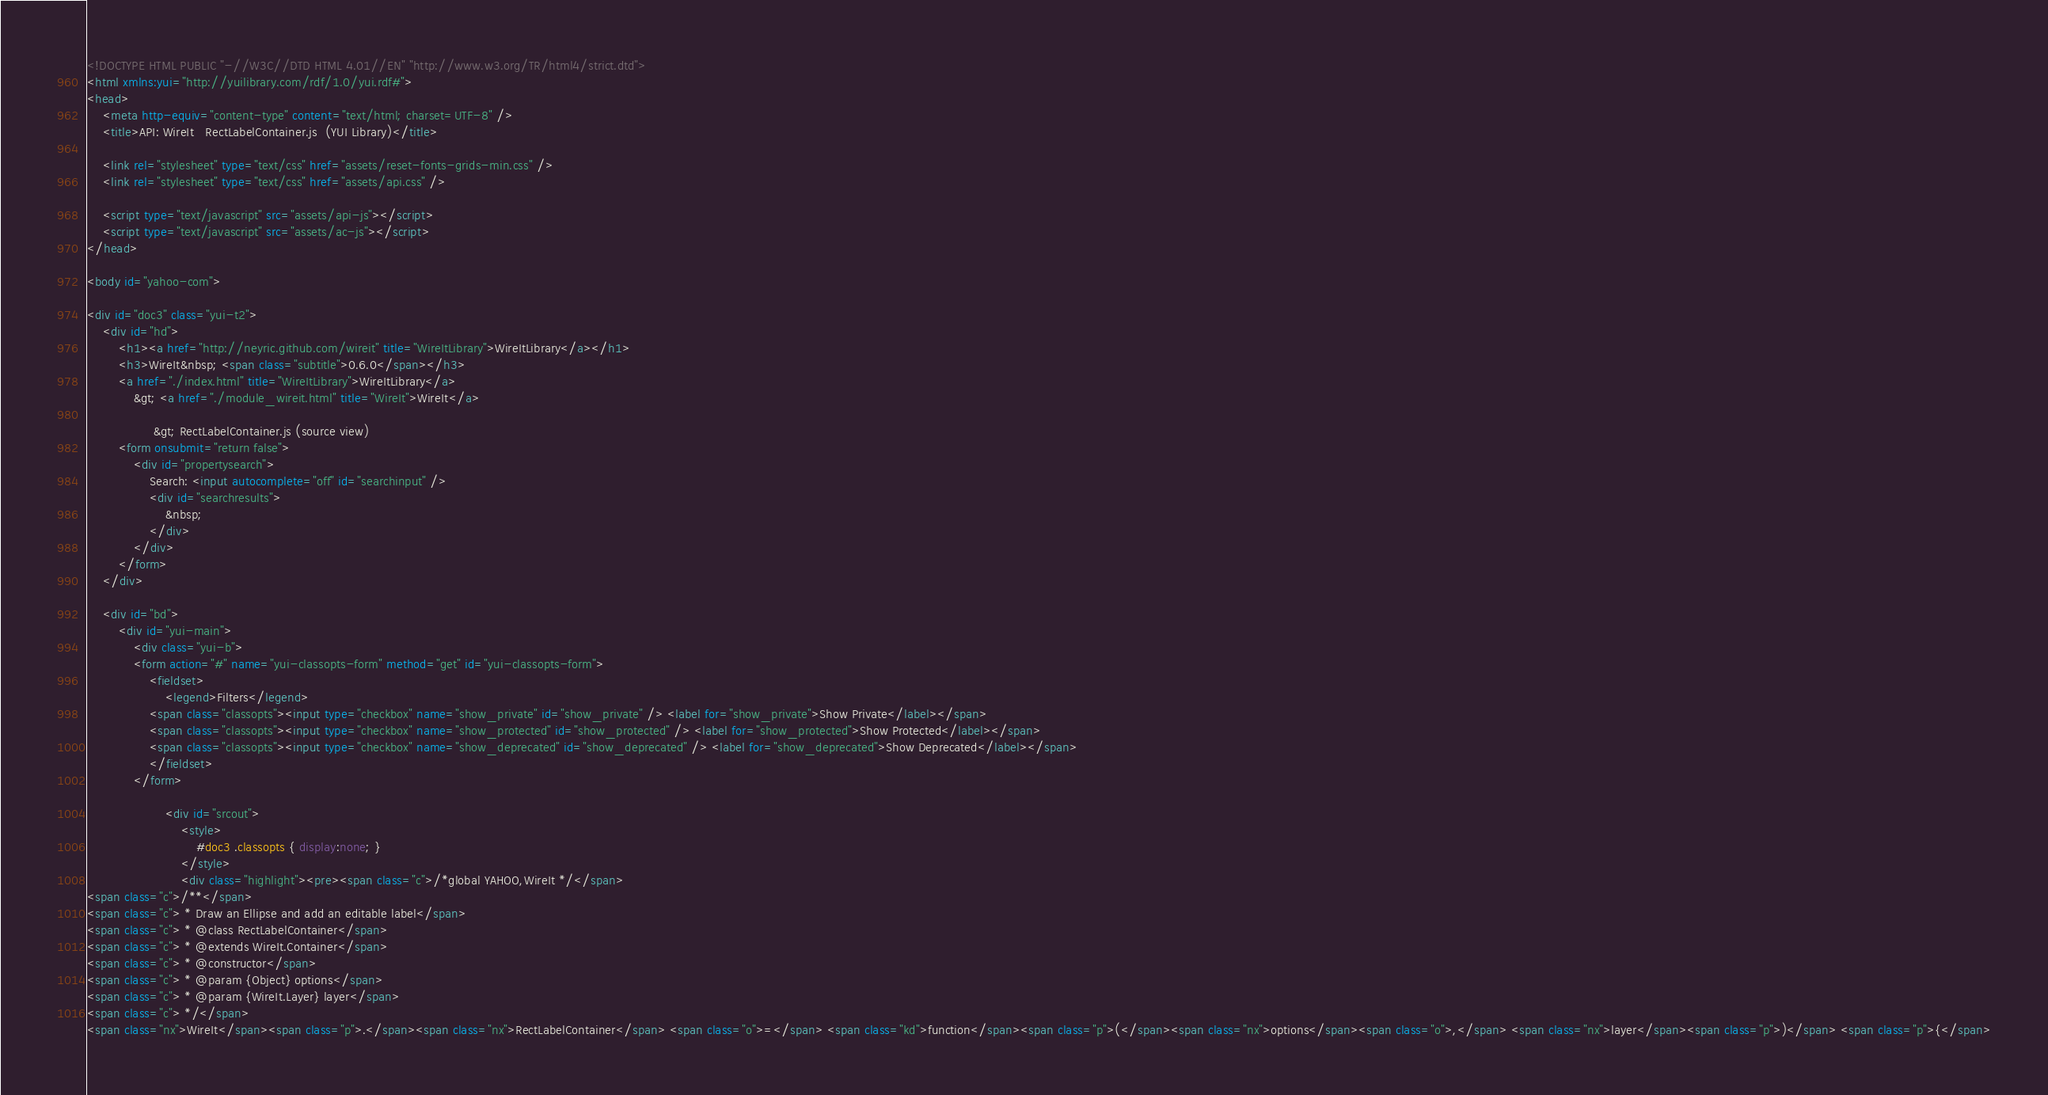Convert code to text. <code><loc_0><loc_0><loc_500><loc_500><_HTML_><!DOCTYPE HTML PUBLIC "-//W3C//DTD HTML 4.01//EN" "http://www.w3.org/TR/html4/strict.dtd">
<html xmlns:yui="http://yuilibrary.com/rdf/1.0/yui.rdf#">
<head>
    <meta http-equiv="content-type" content="text/html; charset=UTF-8" />
	<title>API: WireIt   RectLabelContainer.js  (YUI Library)</title>

	<link rel="stylesheet" type="text/css" href="assets/reset-fonts-grids-min.css" />
	<link rel="stylesheet" type="text/css" href="assets/api.css" />

    <script type="text/javascript" src="assets/api-js"></script>
    <script type="text/javascript" src="assets/ac-js"></script>
</head>

<body id="yahoo-com">

<div id="doc3" class="yui-t2">
	<div id="hd">
        <h1><a href="http://neyric.github.com/wireit" title="WireItLibrary">WireItLibrary</a></h1>
        <h3>WireIt&nbsp; <span class="subtitle">0.6.0</span></h3>
        <a href="./index.html" title="WireItLibrary">WireItLibrary</a> 
            &gt; <a href="./module_wireit.html" title="WireIt">WireIt</a>
                
                 &gt; RectLabelContainer.js (source view) 
        <form onsubmit="return false">
            <div id="propertysearch">
                Search: <input autocomplete="off" id="searchinput" />
                <div id="searchresults">
                    &nbsp;
                </div>
            </div>
        </form>
	</div>

	<div id="bd">
		<div id="yui-main">
			<div class="yui-b">
            <form action="#" name="yui-classopts-form" method="get" id="yui-classopts-form">
                <fieldset>
                    <legend>Filters</legend>
                <span class="classopts"><input type="checkbox" name="show_private" id="show_private" /> <label for="show_private">Show Private</label></span>
                <span class="classopts"><input type="checkbox" name="show_protected" id="show_protected" /> <label for="show_protected">Show Protected</label></span>
                <span class="classopts"><input type="checkbox" name="show_deprecated" id="show_deprecated" /> <label for="show_deprecated">Show Deprecated</label></span>
                </fieldset>
            </form>

                    <div id="srcout">
                        <style>
                            #doc3 .classopts { display:none; }
                        </style>
                        <div class="highlight"><pre><span class="c">/*global YAHOO,WireIt */</span>
<span class="c">/**</span>
<span class="c"> * Draw an Ellipse and add an editable label</span>
<span class="c"> * @class RectLabelContainer</span>
<span class="c"> * @extends WireIt.Container</span>
<span class="c"> * @constructor</span>
<span class="c"> * @param {Object} options</span>
<span class="c"> * @param {WireIt.Layer} layer</span>
<span class="c"> */</span>
<span class="nx">WireIt</span><span class="p">.</span><span class="nx">RectLabelContainer</span> <span class="o">=</span> <span class="kd">function</span><span class="p">(</span><span class="nx">options</span><span class="o">,</span> <span class="nx">layer</span><span class="p">)</span> <span class="p">{</span></code> 